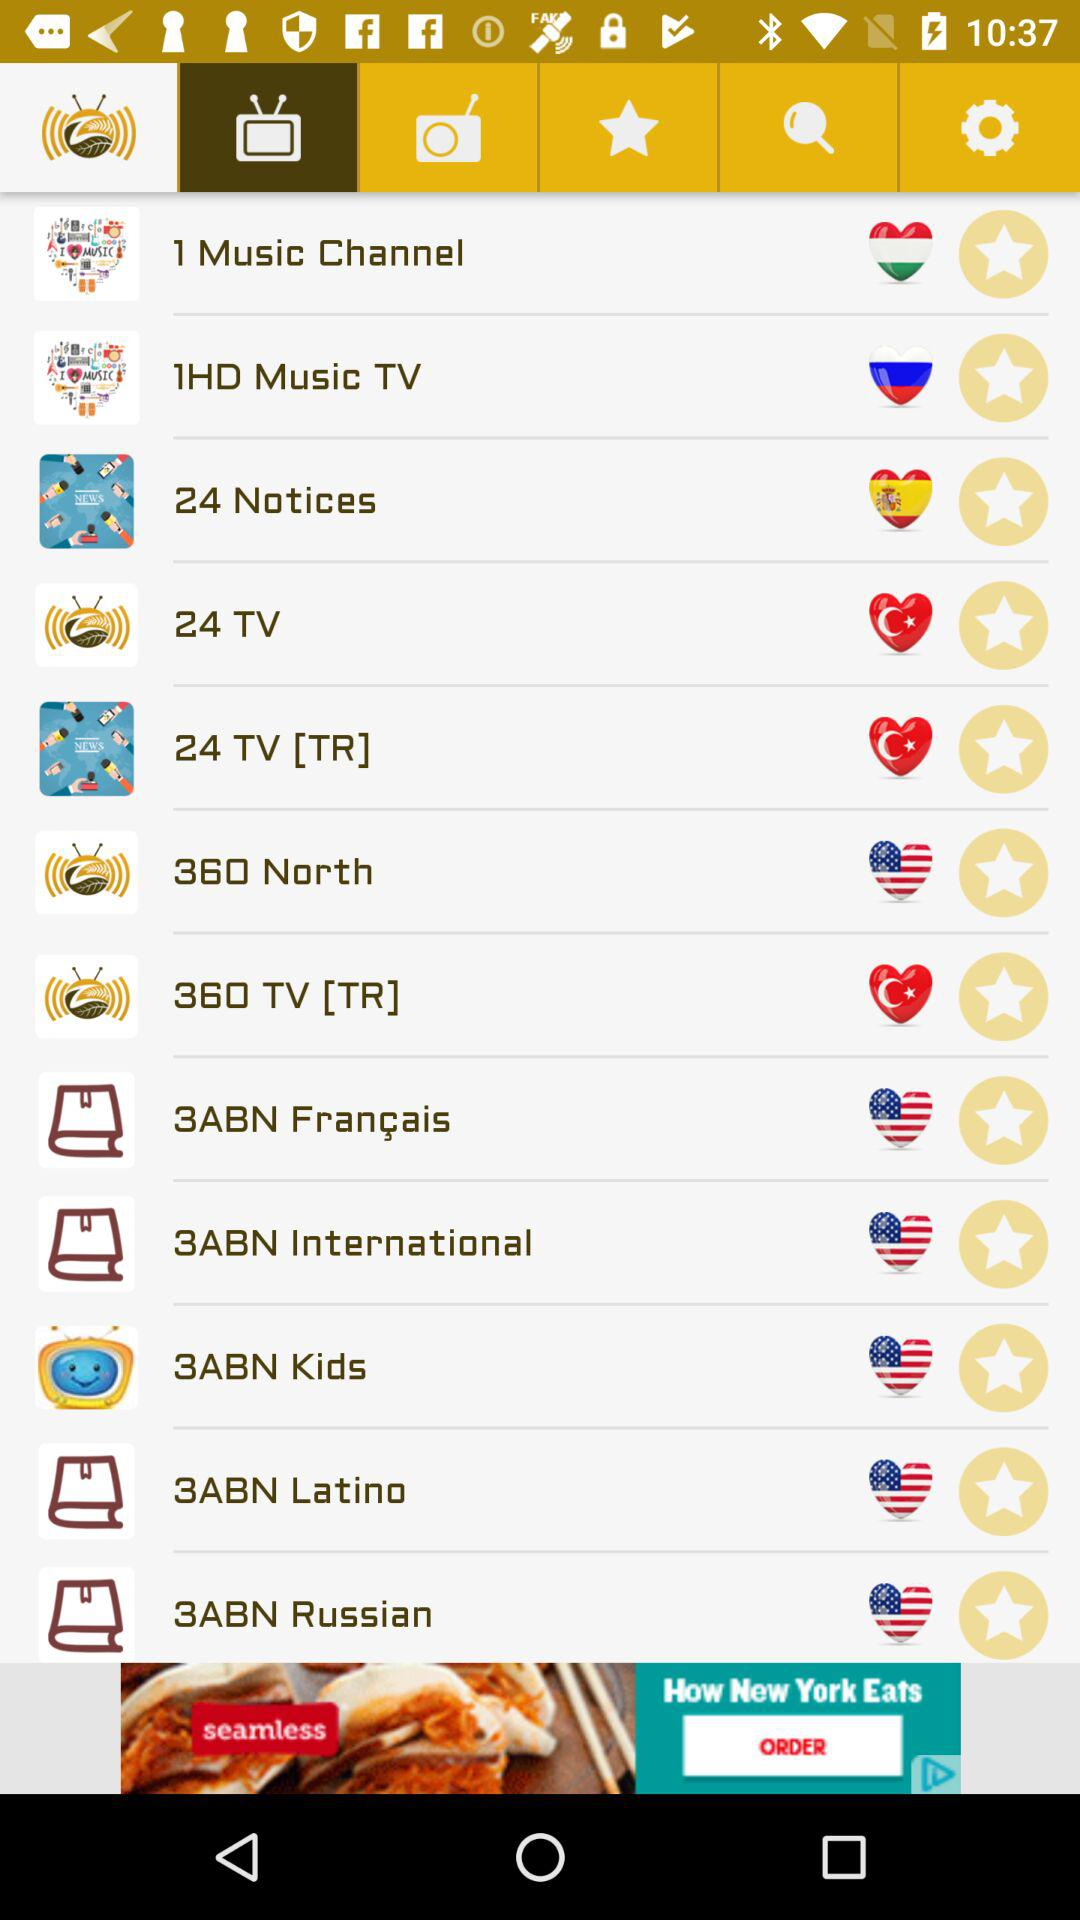What time does "1 Music Channel" stop broadcasting?
When the provided information is insufficient, respond with <no answer>. <no answer> 